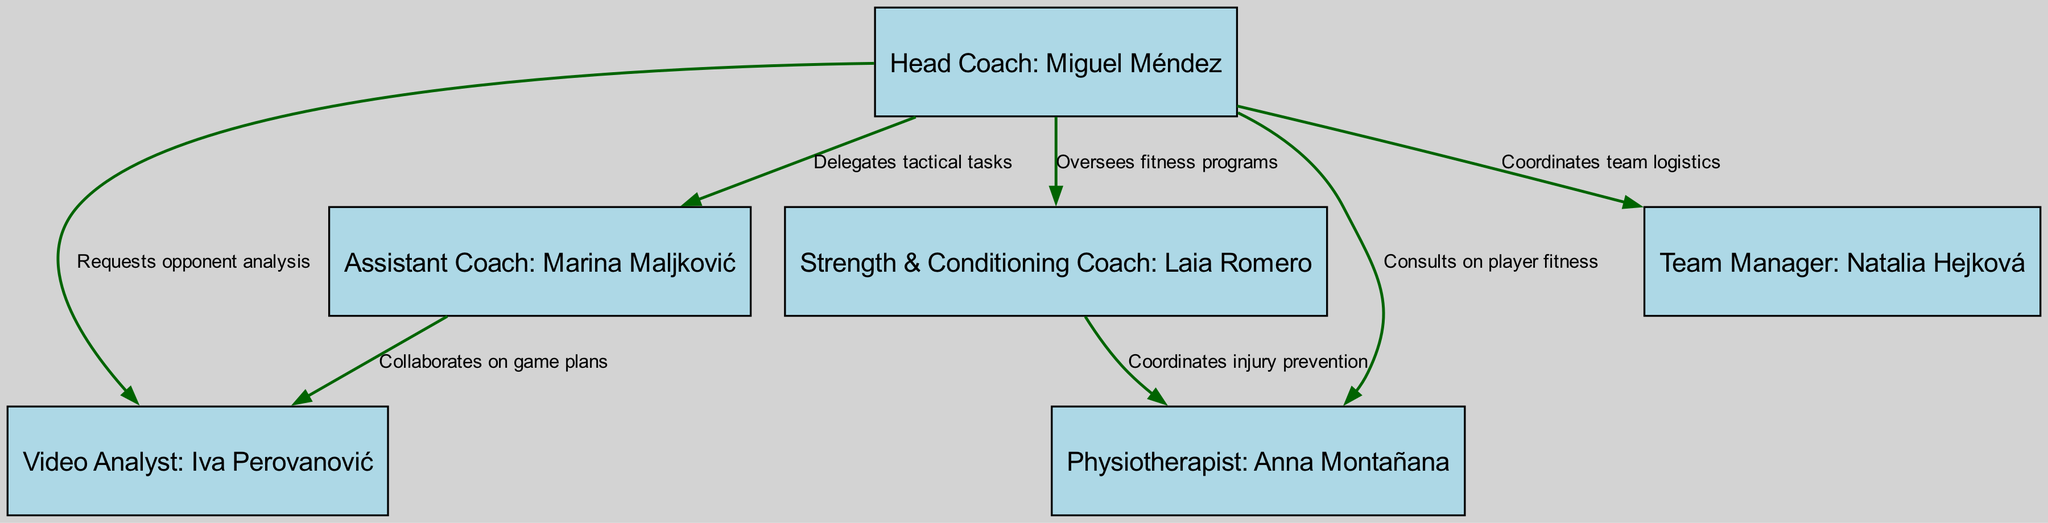What is the role of the head coach? The head coach, Miguel Méndez, is responsible for leading the team and managing all coaching-related tasks. This is evident as he is at the top of the hierarchy and has multiple connections to other staff members, delegating various tasks.
Answer: Head Coach How many edges are in the diagram? Edges represent the relationships or connections between nodes. Counting from the provided edges, we find that there are seven relationships illustrated in the diagram, indicating various delegations and collaborations among the coaching staff.
Answer: 7 Who collaborates with the video analyst on game plans? The assistant coach, Marina Maljković, collaborates with the video analyst, Iva Perovanović, as indicated by the directed edge that shows collaboration on game plans.
Answer: Assistant Coach Which coach coordinates injury prevention? The strength & conditioning coach, Laia Romero, is responsible for coordinating injury prevention as shown by the directed edge connecting her to the physiotherapist, Anna Montañana.
Answer: Strength & Conditioning Coach What is the main responsibility of the team manager? The team manager, Natalia Hejková, coordinates team logistics, which is detailed in the diagram by showing a direct relationship with the head coach who delegates this responsibility to her.
Answer: Coordinates team logistics How does the head coach interact with the physiotherapist? The head coach consults with the physiotherapist regarding player fitness, as indicated by the directed edge from the head coach to the physio, showing a direct consultative relationship.
Answer: Consults on player fitness Which two roles have a direct collaboration between them in this hierarchy? The assistant coach and the video analyst have a direct collaboration on game plans, depicted by a directed edge indicating their cooperative relationship.
Answer: Assistant Coach & Video Analyst What does the strength and conditioning coach oversee? The strength & conditioning coach, Laia Romero, oversees fitness programs, as noted from the directed edge showing her relationship with the head coach, who delegates this responsibility to her.
Answer: Fitness programs 